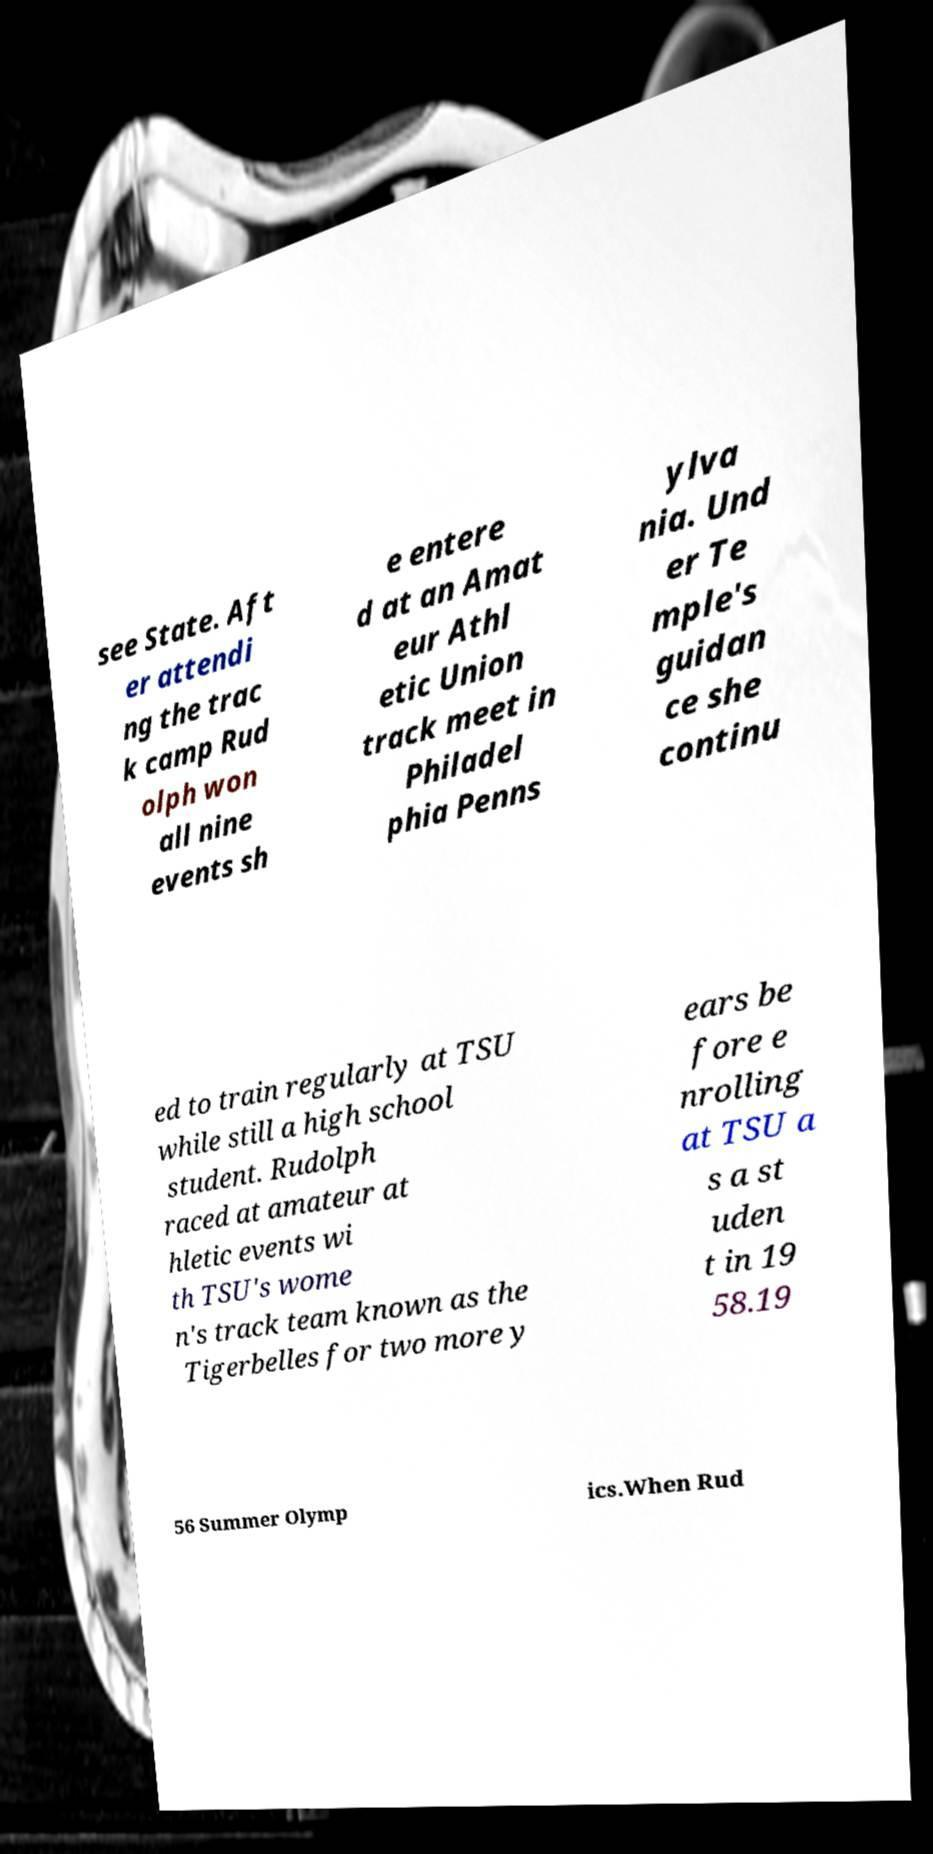For documentation purposes, I need the text within this image transcribed. Could you provide that? see State. Aft er attendi ng the trac k camp Rud olph won all nine events sh e entere d at an Amat eur Athl etic Union track meet in Philadel phia Penns ylva nia. Und er Te mple's guidan ce she continu ed to train regularly at TSU while still a high school student. Rudolph raced at amateur at hletic events wi th TSU's wome n's track team known as the Tigerbelles for two more y ears be fore e nrolling at TSU a s a st uden t in 19 58.19 56 Summer Olymp ics.When Rud 